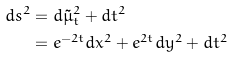Convert formula to latex. <formula><loc_0><loc_0><loc_500><loc_500>d s ^ { 2 } & = d \tilde { \mu } _ { t } ^ { 2 } + d t ^ { 2 } \\ & = e ^ { - 2 t } d x ^ { 2 } + e ^ { 2 t } d y ^ { 2 } + d t ^ { 2 }</formula> 